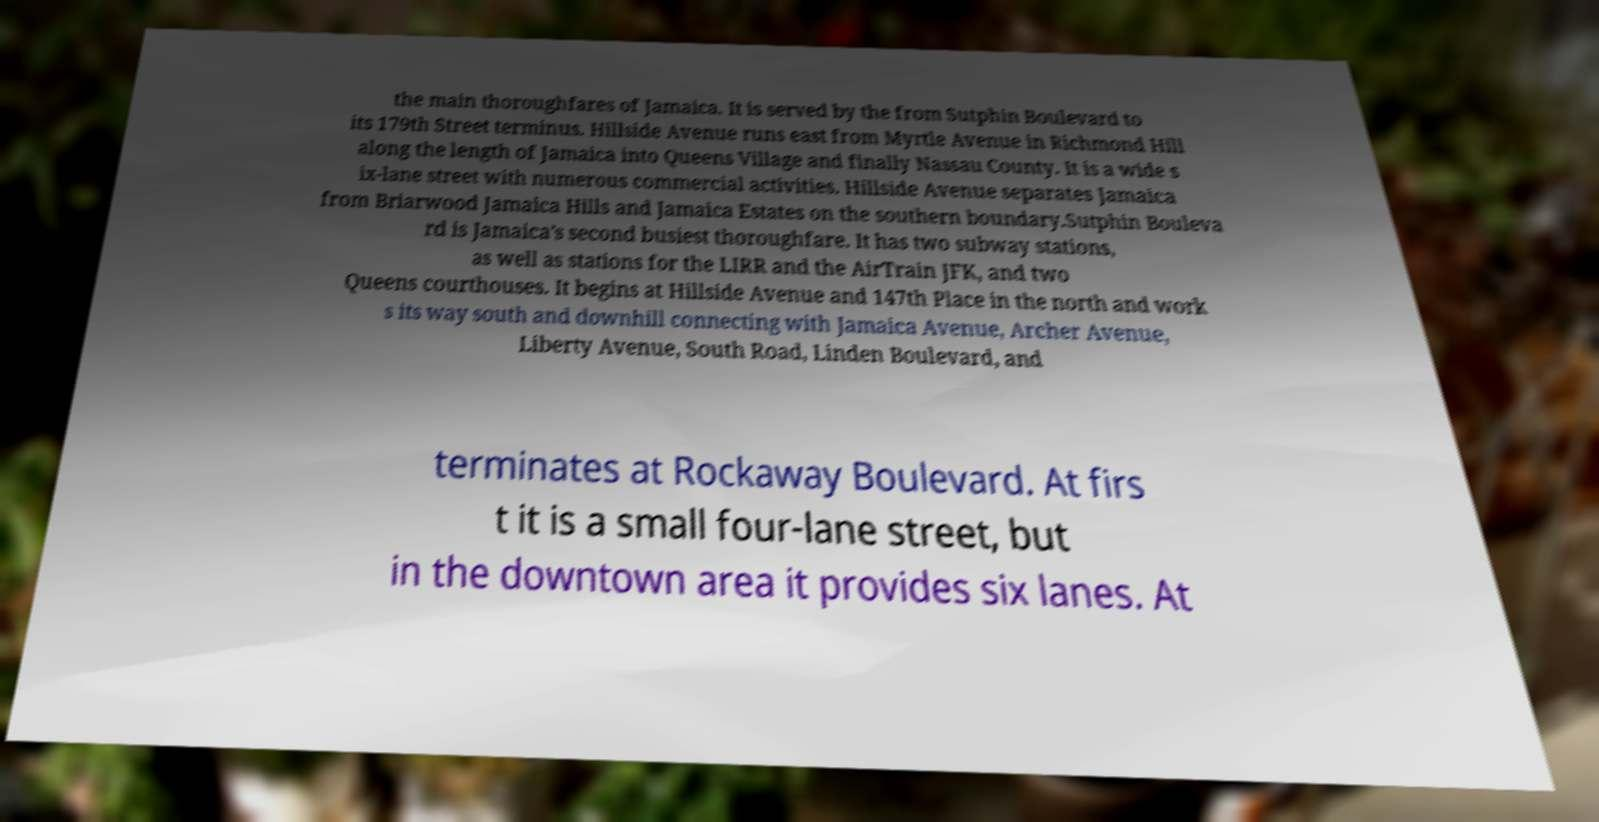For documentation purposes, I need the text within this image transcribed. Could you provide that? the main thoroughfares of Jamaica. It is served by the from Sutphin Boulevard to its 179th Street terminus. Hillside Avenue runs east from Myrtle Avenue in Richmond Hill along the length of Jamaica into Queens Village and finally Nassau County. It is a wide s ix-lane street with numerous commercial activities. Hillside Avenue separates Jamaica from Briarwood Jamaica Hills and Jamaica Estates on the southern boundary.Sutphin Bouleva rd is Jamaica's second busiest thoroughfare. It has two subway stations, as well as stations for the LIRR and the AirTrain JFK, and two Queens courthouses. It begins at Hillside Avenue and 147th Place in the north and work s its way south and downhill connecting with Jamaica Avenue, Archer Avenue, Liberty Avenue, South Road, Linden Boulevard, and terminates at Rockaway Boulevard. At firs t it is a small four-lane street, but in the downtown area it provides six lanes. At 